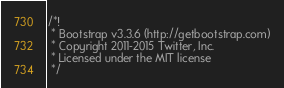<code> <loc_0><loc_0><loc_500><loc_500><_JavaScript_>/*!
 * Bootstrap v3.3.6 (http://getbootstrap.com)
 * Copyright 2011-2015 Twitter, Inc.
 * Licensed under the MIT license
 */</code> 